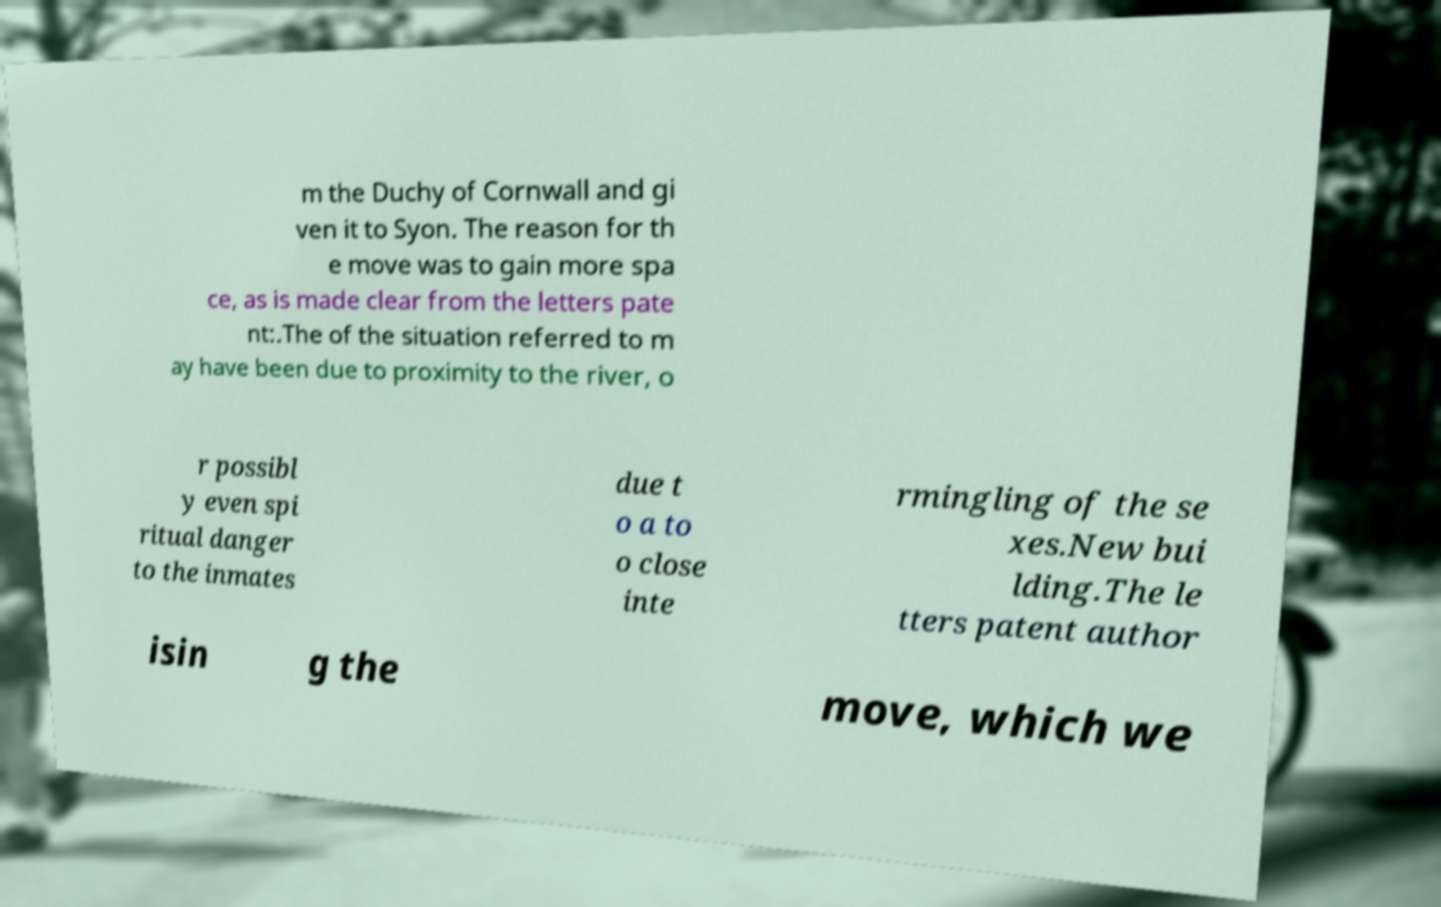Please read and relay the text visible in this image. What does it say? m the Duchy of Cornwall and gi ven it to Syon. The reason for th e move was to gain more spa ce, as is made clear from the letters pate nt:.The of the situation referred to m ay have been due to proximity to the river, o r possibl y even spi ritual danger to the inmates due t o a to o close inte rmingling of the se xes.New bui lding.The le tters patent author isin g the move, which we 